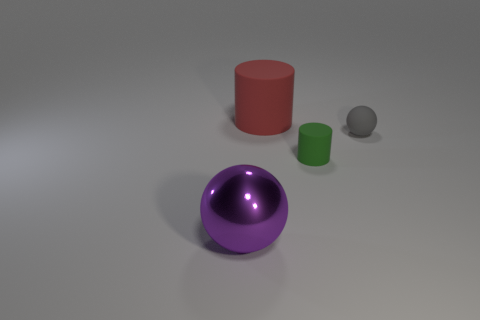Add 3 gray rubber objects. How many objects exist? 7 Add 2 green matte cylinders. How many green matte cylinders exist? 3 Subtract 0 yellow spheres. How many objects are left? 4 Subtract all small green objects. Subtract all red matte things. How many objects are left? 2 Add 4 large red cylinders. How many large red cylinders are left? 5 